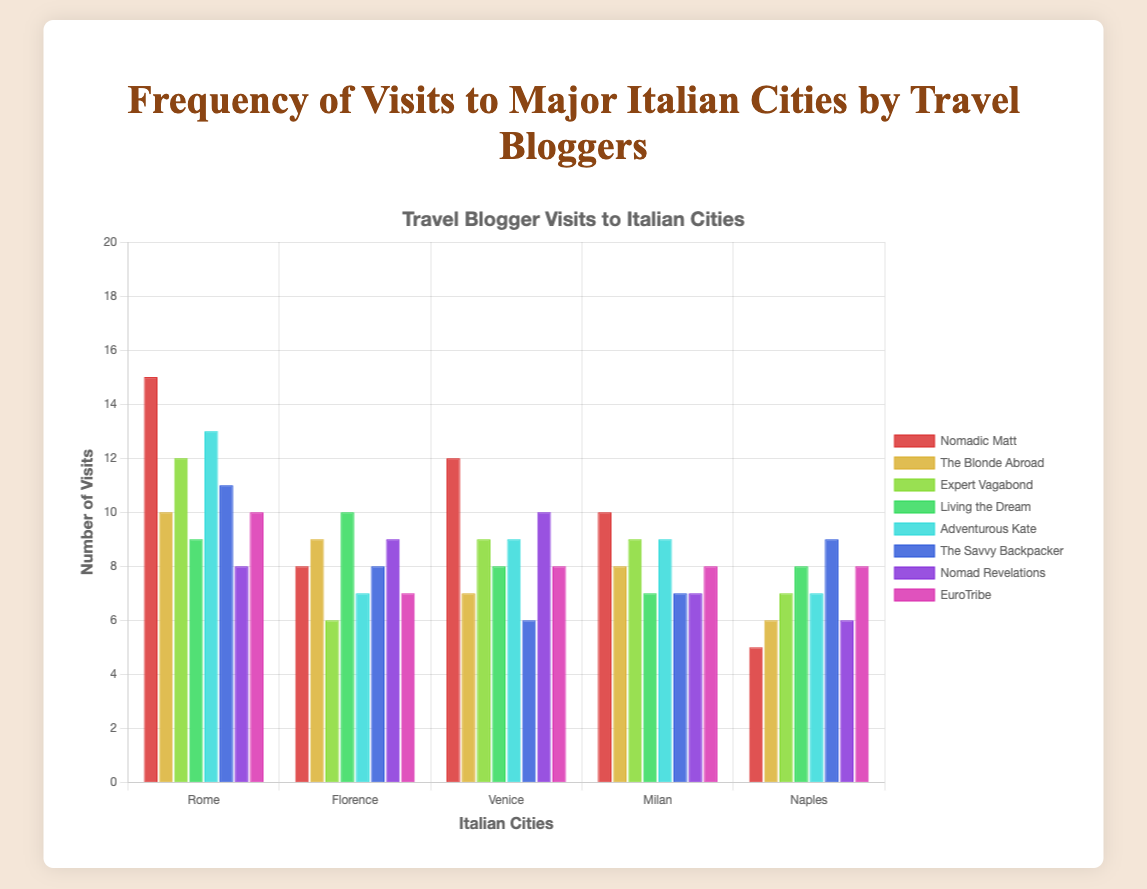How many visits did "Adventurous Kate" make to Rome and Florence combined? First, identify the number of visits to Rome by "Adventurous Kate", which is 13. Next, identify her visits to Florence, which is 7. Add these two numbers together: 13 + 7 = 20.
Answer: 20 Which travel blogger visited Naples the most? First, list the number of visits to Naples for each blogger: "Nomadic Matt" (5), "The Blonde Abroad" (6), "Expert Vagabond" (7), "Living the Dream" (8), "Adventurous Kate" (7), "The Savvy Backpacker" (9), "Nomad Revelations" (6), and "EuroTribe" (8). The highest of these numbers is 9, which is the number of visits "The Savvy Backpacker" made to Naples.
Answer: The Savvy Backpacker Does "Nomadic Matt" visit Milan more times than "Nomad Revelations"? First, find the number of visits to Milan by "Nomadic Matt", which is 10. Then, find the number of visits to Milan by "Nomad Revelations", which is 7. Compare these numbers: 10 > 7, which means "Nomadic Matt" visits Milan more than "Nomad Revelations".
Answer: Yes Which city has the highest total number of visits by all bloggers? Sum the number of visits for all bloggers for each city: 
Rome: 15+10+12+9+13+11+8+10 = 88
Florence: 8+9+6+10+7+8+9+7 = 64
Venice: 12+7+9+8+9+6+10+8 = 69
Milan: 10+8+9+7+9+7+7+8 = 65
Naples: 5+6+7+8+7+9+6+8 = 56
The highest total is for Rome, with 88 visits.
Answer: Rome By how much does "Nomadic Matt's" visits to Rome exceed "The Blonde Abroad's" visits to Venice? First, find "Nomadic Matt's" visits to Rome, which is 15. Find "The Blonde Abroad's" visits to Venice, which is 7. Subtract these two numbers: 15 - 7 = 8.
Answer: 8 Which two bloggers have the most similar number of visits to Venice? The visits to Venice for each blogger are:
"Nomadic Matt" (12), "The Blonde Abroad" (7), "Expert Vagabond" (9), "Living the Dream" (8), "Adventurous Kate" (9), "The Savvy Backpacker" (6), "Nomad Revelations" (10), "EuroTribe" (8). The most similar values are "Living the Dream" (8) and "EuroTribe" (8).
Answer: Living the Dream, EuroTribe From the data, who has the largest variation in the number of visits to different cities? Calculate the range (maximum minus minimum) of visits for each blogger:
"Nomadic Matt": max(15, 8, 12, 10, 5) - min(15, 8, 12, 10, 5) = 15 - 5 = 10
"The Blonde Abroad": max(10, 9, 7, 8, 6) - min(10, 9, 7, 8, 6) = 10 - 6 = 4
"Expert Vagabond": max(12, 6, 9, 9, 7) - min(12, 6, 9, 9, 7) = 12 - 6 = 6
"Living the Dream": max(9, 10, 8, 7, 8) - min(9, 10, 8, 7, 8) = 10 - 7 = 3
"Adventurous Kate": max(13, 7, 9, 9, 7) - min(13, 7, 9, 9, 7) = 13 - 7 = 6
"The Savvy Backpacker": max(11, 8, 6, 7, 9) - min(11, 8, 6, 7, 9) = 11 - 6 = 5
"Nomad Revelations": max(8, 9, 10, 7, 6) - min(8, 9, 10, 7, 6) = 10 - 6 = 4
"EuroTribe": max(10, 7, 8, 8, 8) - min(10, 7, 8, 8, 8) = 10 - 7 = 3
The largest of these is 10 for "Nomadic Matt".
Answer: Nomadic Matt 